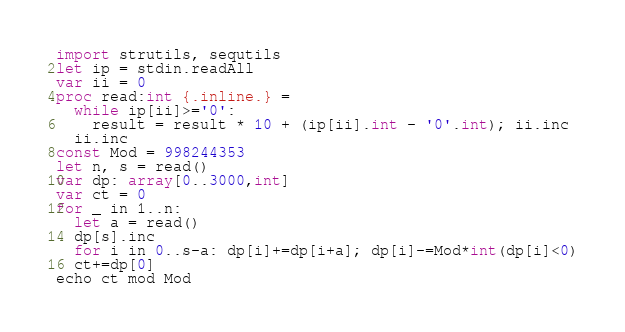<code> <loc_0><loc_0><loc_500><loc_500><_Nim_>import strutils, sequtils
let ip = stdin.readAll
var ii = 0
proc read:int {.inline.} =
  while ip[ii]>='0':
    result = result * 10 + (ip[ii].int - '0'.int); ii.inc
  ii.inc
const Mod = 998244353
let n, s = read()
var dp: array[0..3000,int]
var ct = 0
for _ in 1..n:
  let a = read()
  dp[s].inc
  for i in 0..s-a: dp[i]+=dp[i+a]; dp[i]-=Mod*int(dp[i]<0)
  ct+=dp[0]
echo ct mod Mod</code> 